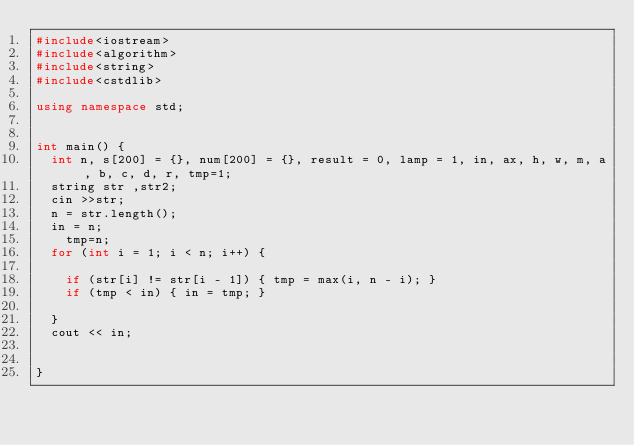<code> <loc_0><loc_0><loc_500><loc_500><_C++_>#include<iostream>
#include<algorithm>
#include<string>
#include<cstdlib>

using namespace std;


int main() {
	int n, s[200] = {}, num[200] = {}, result = 0, lamp = 1, in, ax, h, w, m, a, b, c, d, r, tmp=1;
	string str ,str2;
	cin >>str;
	n = str.length();
	in = n;
  	tmp=n;
	for (int i = 1; i < n; i++) {
        
		if (str[i] != str[i - 1]) { tmp = max(i, n - i); }
		if (tmp < in) { in = tmp; }
    
	}
	cout << in;
	

}</code> 